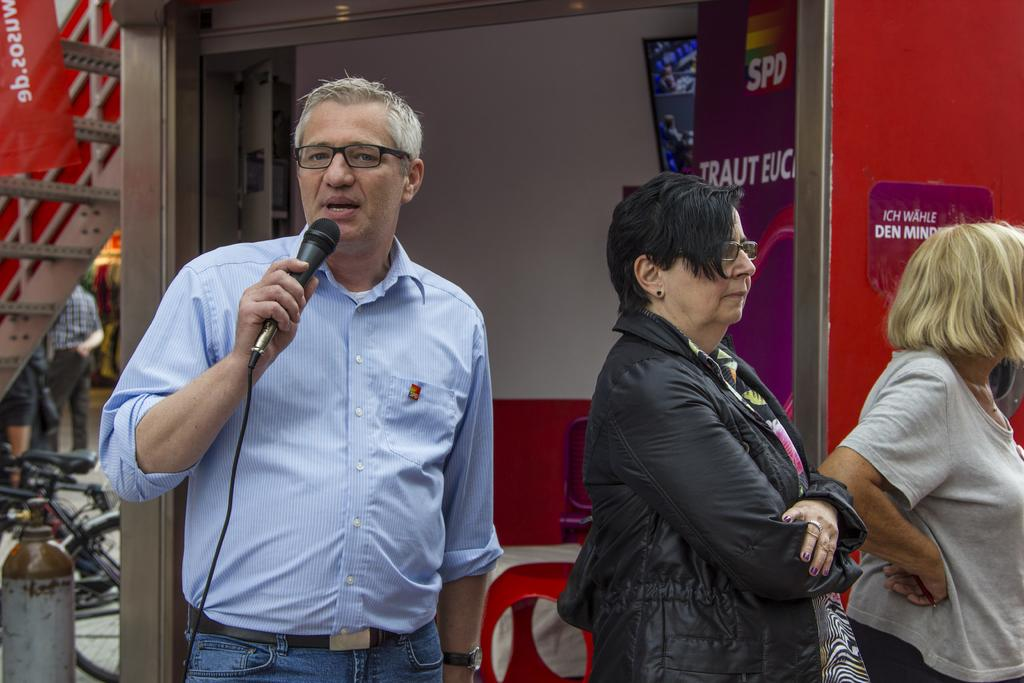How many people are in the image? There are three people in the image. Can you describe the gender of the people in the image? One of them is a man, and there are two women in the image. What is the man holding in the image? The man is holding a microphone. What can be seen in the background of the image? There is a wall in the background of the image. What type of beetle can be seen crawling on the wall in the image? There is no beetle present in the image; only the wall is visible in the background. How many houses are visible in the image? There are no houses visible in the image; only the wall is visible in the background. 